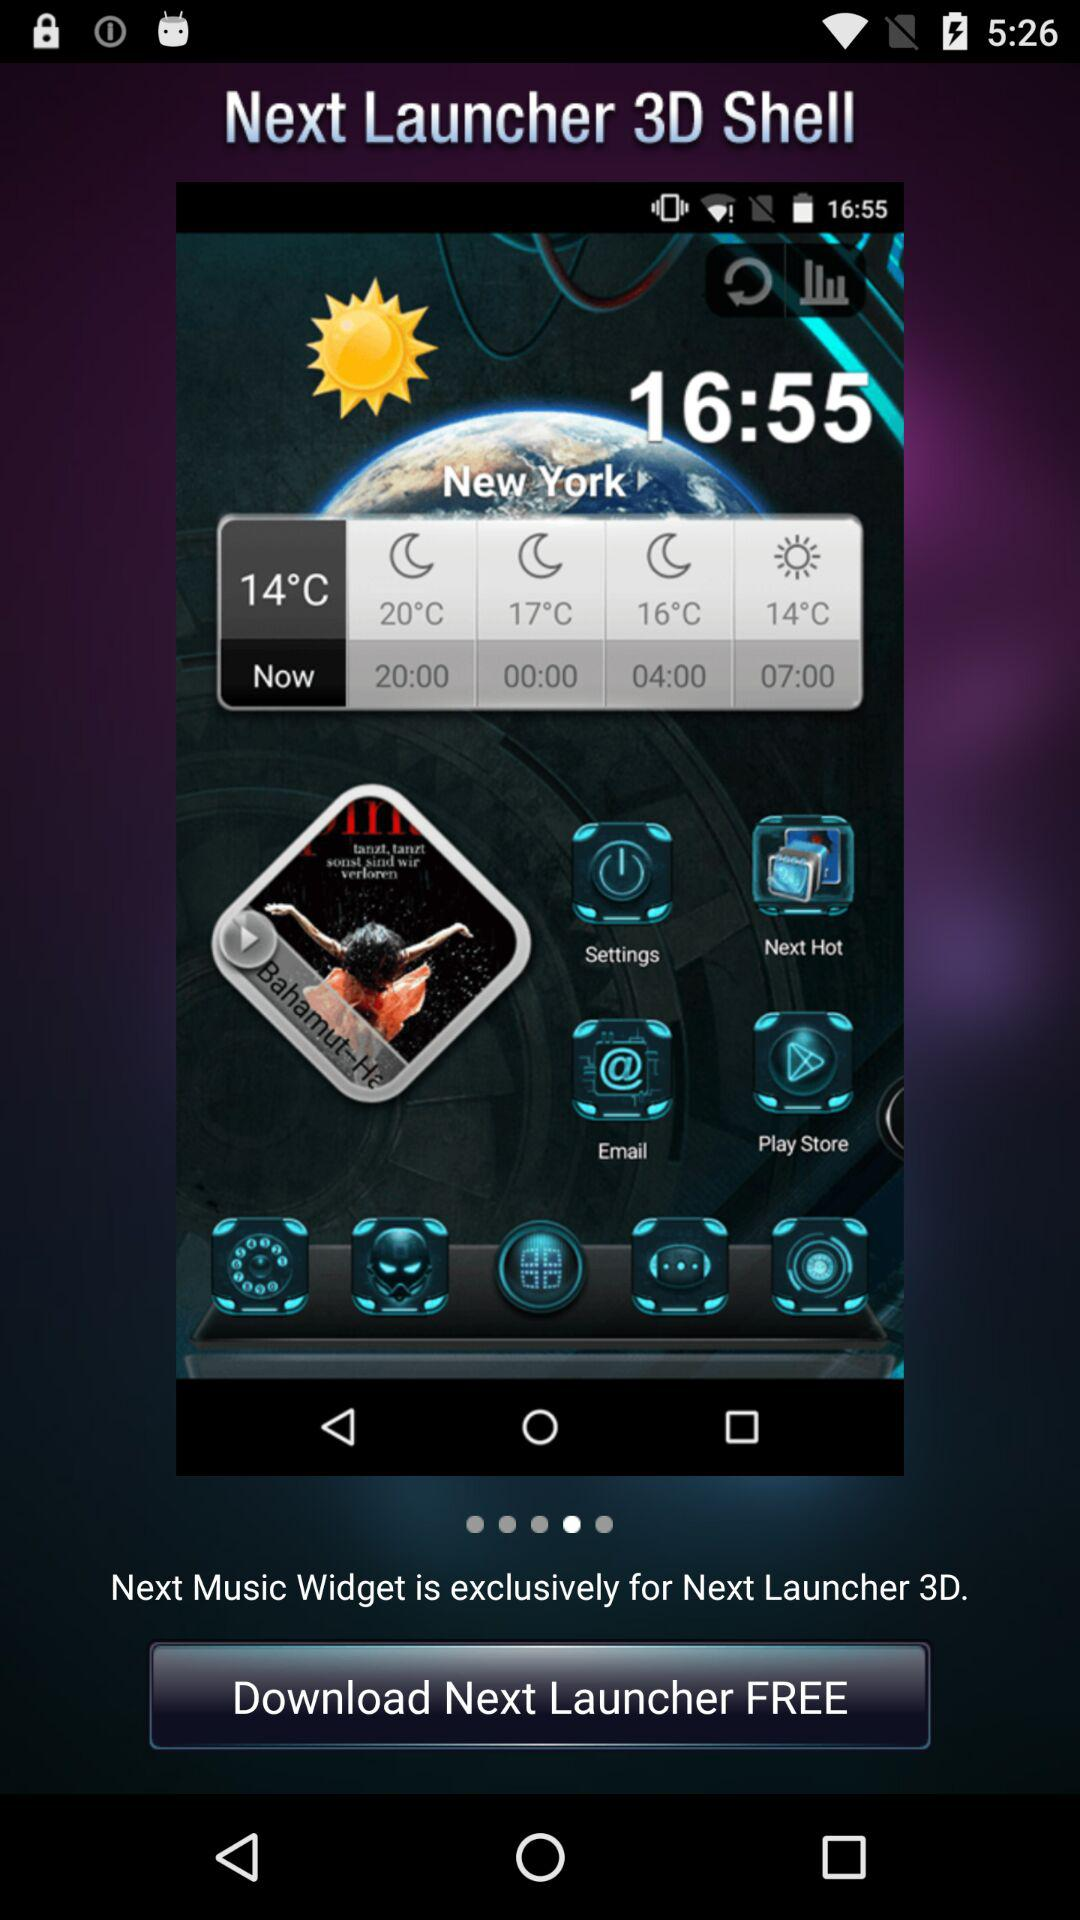What is the application name? The application name is "Next Launcher 3D Shell". 